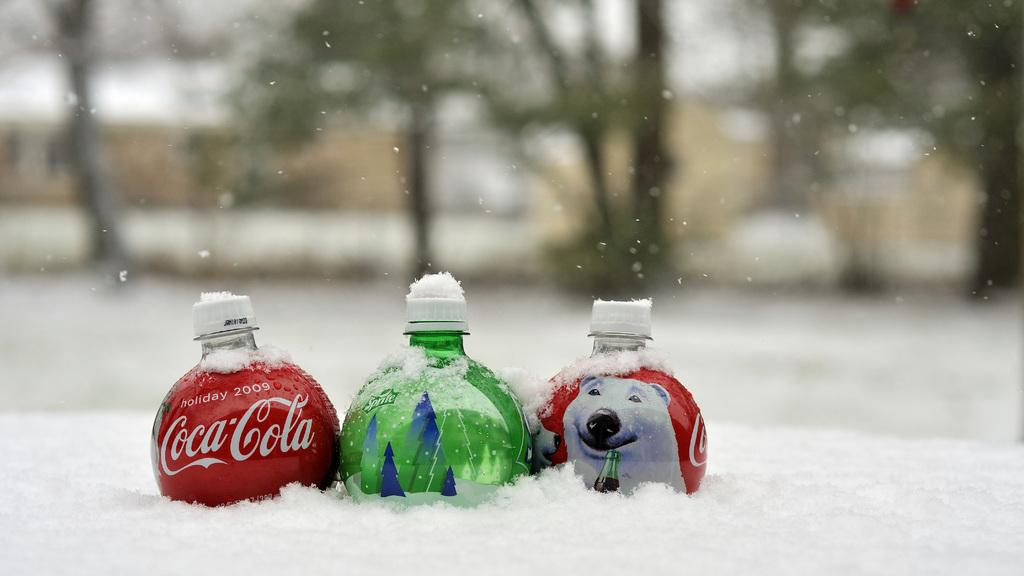How many bottles are visible in the image? There are three bottles in the image. What is the condition of the bottles in the image? The bottles are covered in snow. What can be observed about the colors of the bottles? The bottles are in different colors. What is written on the bottles? The bottles have texts on them. What can be seen in the background of the image? There are trees in the background of the image. What type of payment is required to learn about the history of the bottles in the image? There is no mention of history or payment in the image, so it is not possible to answer that question. 